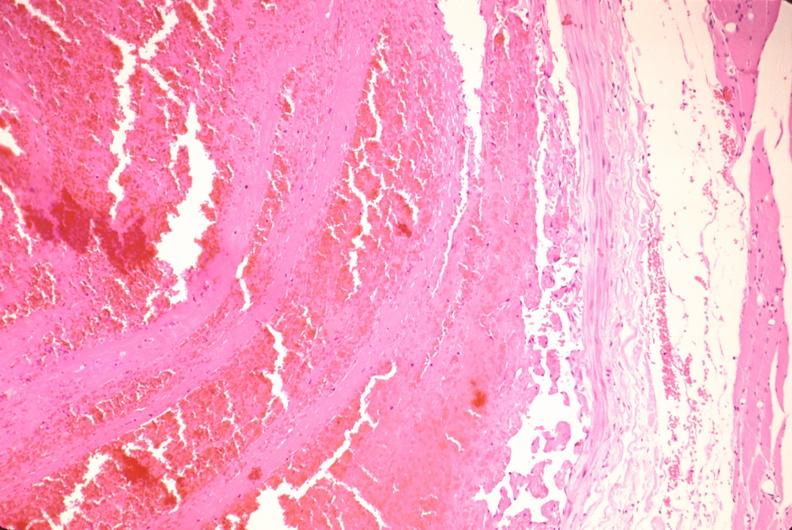s cardiovascular present?
Answer the question using a single word or phrase. Yes 